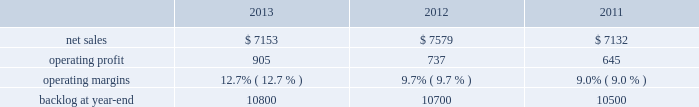Mfc 2019s operating profit for 2013 increased $ 175 million , or 14% ( 14 % ) , compared to 2012 .
The increase was primarily attributable to higher operating profit of approximately $ 85 million for air and missile defense programs ( thaad and pac-3 ) due to increased risk retirements and volume ; about $ 85 million for fire control programs ( sniper ae , lantirn ae and apache ) due to increased risk retirements and higher volume ; and approximately $ 75 million for tactical missile programs ( hellfire and various programs ) due to increased risk retirements .
The increases were partially offset by lower operating profit of about $ 45 million for the resolution of contractual matters in the second quarter of 2012 ; and approximately $ 15 million for various technical services programs due to lower volume partially offset by increased risk retirements .
Adjustments not related to volume , including net profit booking rate adjustments and other matters , were approximately $ 100 million higher for 2013 compared to 2012 .
2012 compared to 2011 mfc 2019s net sales for 2012 were comparable to 2011 .
Net sales decreased approximately $ 130 million due to lower volume and risk retirements on various services programs , and about $ 60 million due to lower volume from fire control systems programs ( primarily sniper ae ; lantirn ae ; and apache ) .
The decreases largely were offset by higher net sales of approximately $ 95 million due to higher volume from tactical missile programs ( primarily javelin and hellfire ) and approximately $ 80 million for air and missile defense programs ( primarily pac-3 and thaad ) .
Mfc 2019s operating profit for 2012 increased $ 187 million , or 17% ( 17 % ) , compared to 2011 .
The increase was attributable to higher risk retirements and volume of about $ 95 million from tactical missile programs ( primarily javelin and hellfire ) ; increased risk retirements and volume of approximately $ 60 million for air and missile defense programs ( primarily thaad and pac-3 ) ; and about $ 45 million from a resolution of contractual matters .
Partially offsetting these increases was lower risk retirements and volume on various programs , including $ 25 million for services programs .
Adjustments not related to volume , including net profit booking rate adjustments and other matters described above , were approximately $ 145 million higher for 2012 compared to 2011 .
Backlog backlog increased in 2013 compared to 2012 mainly due to higher orders on the thaad program and lower sales volume compared to new orders on certain fire control systems programs in 2013 , partially offset by lower orders on technical services programs and certain tactical missile programs .
Backlog increased in 2012 compared to 2011 mainly due to increased orders and lower sales on fire control systems programs ( primarily lantirn ae and sniper ae ) and on various services programs , partially offset by lower orders and higher sales volume on tactical missiles programs .
Trends we expect mfc 2019s net sales to be flat to slightly down in 2014 compared to 2013 , primarily due to a decrease in net sales on technical services programs partially offset by an increase in net sales from missiles and fire control programs .
Operating profit is expected to decrease in the high single digit percentage range , driven by a reduction in expected risk retirements in 2014 .
Accordingly , operating profit margin is expected to slightly decline from 2013 .
Mission systems and training our mst business segment provides ship and submarine mission and combat systems ; mission systems and sensors for rotary and fixed-wing aircraft ; sea and land-based missile defense systems ; radar systems ; littoral combat ships ; simulation and training services ; and unmanned systems and technologies .
Mst 2019s major programs include aegis combat system ( aegis ) , lcs , mh-60 , tpq-53 radar system , and mk-41 vertical launching system ( vls ) .
Mst 2019s operating results included the following ( in millions ) : .
2013 compared to 2012 mst 2019s net sales for 2013 decreased $ 426 million , or 6% ( 6 % ) , compared to 2012 .
The decrease was primarily attributable to lower net sales of approximately $ 275 million for various ship and aviation systems programs due to lower volume .
What was the ratio of the net increase sales leading to the net increase in the operating profit in 2012 to the net decrease in the sales? 
Computations: (((85 + 85) + 75) / (45 + 15))
Answer: 4.08333. 